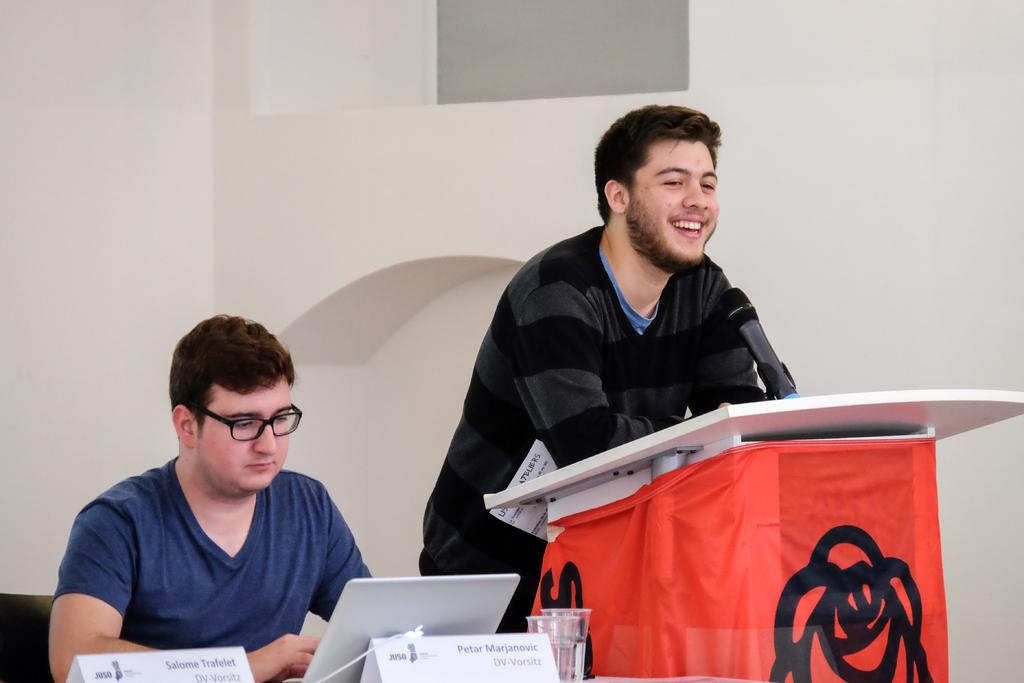How many people are in the image? There are two persons in the image. What object is present for speaking purposes? There is a microphone in the image. What is the person standing behind likely to use? There is a podium in the image, which the person might use for speaking or holding notes. What can be seen near the persons in the image? There are name boards in the image. What objects might the persons be using? There are glasses in the image, which the persons might be using for drinking or as a prop. Can you describe the background of the image? There is a wall in the background of the image, and there is an object in the background as well. What type of zipper can be seen on the person's clothing in the image? There is no zipper visible on the person's clothing in the image. What role does the manager play in the image? There is no mention of a manager in the image or the provided facts. 